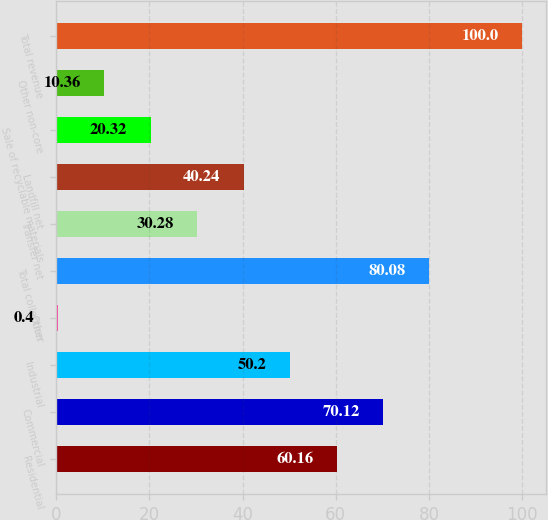Convert chart. <chart><loc_0><loc_0><loc_500><loc_500><bar_chart><fcel>Residential<fcel>Commercial<fcel>Industrial<fcel>Other<fcel>Total collection<fcel>Transfer net<fcel>Landfill net<fcel>Sale of recyclable materials<fcel>Other non-core<fcel>Total revenue<nl><fcel>60.16<fcel>70.12<fcel>50.2<fcel>0.4<fcel>80.08<fcel>30.28<fcel>40.24<fcel>20.32<fcel>10.36<fcel>100<nl></chart> 